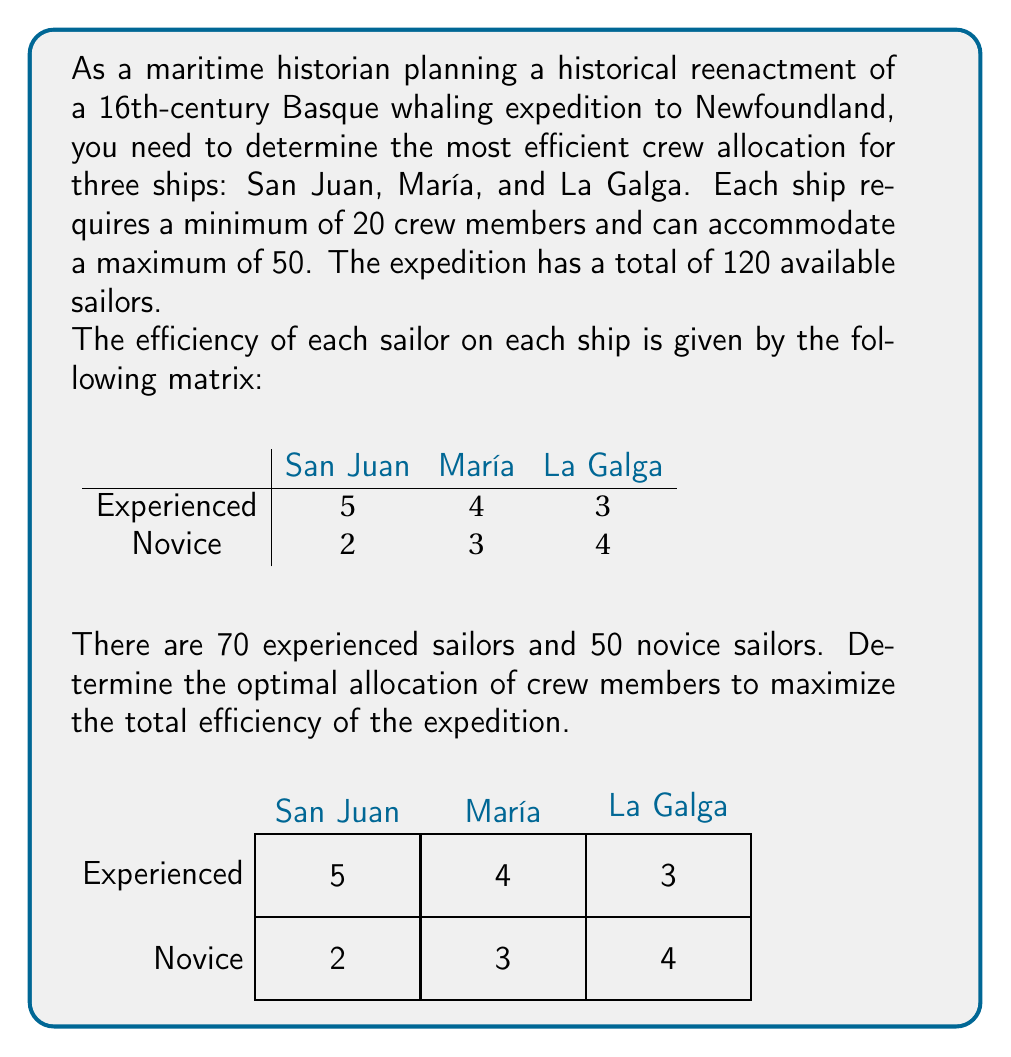Can you solve this math problem? To solve this problem, we'll use linear programming. Let's define our variables:

$x_1$: Experienced sailors on San Juan
$x_2$: Experienced sailors on María
$x_3$: Experienced sailors on La Galga
$y_1$: Novice sailors on San Juan
$y_2$: Novice sailors on María
$y_3$: Novice sailors on La Galga

Our objective function to maximize is:
$$5x_1 + 4x_2 + 3x_3 + 2y_1 + 3y_2 + 4y_3$$

Subject to the following constraints:

1. Total sailors constraint:
   $$x_1 + x_2 + x_3 + y_1 + y_2 + y_3 = 120$$

2. Experienced sailors constraint:
   $$x_1 + x_2 + x_3 \leq 70$$

3. Novice sailors constraint:
   $$y_1 + y_2 + y_3 \leq 50$$

4. Minimum crew per ship:
   $$x_1 + y_1 \geq 20$$
   $$x_2 + y_2 \geq 20$$
   $$x_3 + y_3 \geq 20$$

5. Maximum crew per ship:
   $$x_1 + y_1 \leq 50$$
   $$x_2 + y_2 \leq 50$$
   $$x_3 + y_3 \leq 50$$

6. Non-negativity constraints:
   $$x_1, x_2, x_3, y_1, y_2, y_3 \geq 0$$

Using a linear programming solver, we obtain the optimal solution:

$x_1 = 50, x_2 = 20, x_3 = 0, y_1 = 0, y_2 = 30, y_3 = 20$

This allocation maximizes the total efficiency at 410 units.
Answer: San Juan: 50 experienced, 0 novice; María: 20 experienced, 30 novice; La Galga: 0 experienced, 20 novice. 